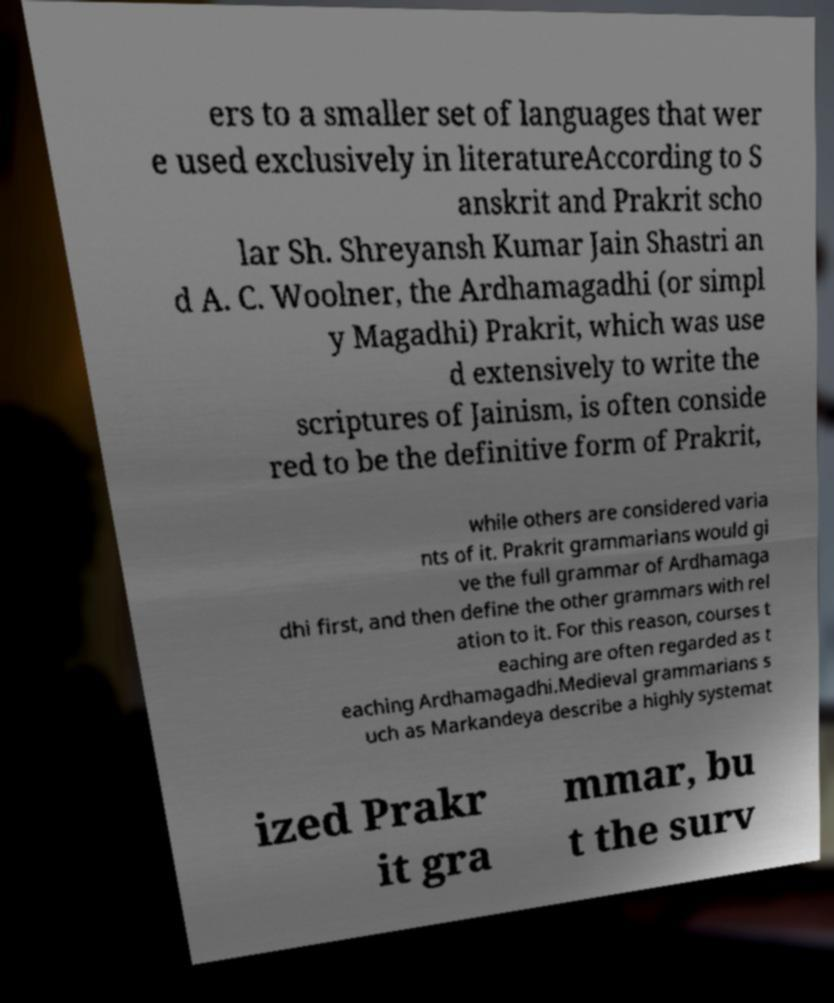For documentation purposes, I need the text within this image transcribed. Could you provide that? ers to a smaller set of languages that wer e used exclusively in literatureAccording to S anskrit and Prakrit scho lar Sh. Shreyansh Kumar Jain Shastri an d A. C. Woolner, the Ardhamagadhi (or simpl y Magadhi) Prakrit, which was use d extensively to write the scriptures of Jainism, is often conside red to be the definitive form of Prakrit, while others are considered varia nts of it. Prakrit grammarians would gi ve the full grammar of Ardhamaga dhi first, and then define the other grammars with rel ation to it. For this reason, courses t eaching are often regarded as t eaching Ardhamagadhi.Medieval grammarians s uch as Markandeya describe a highly systemat ized Prakr it gra mmar, bu t the surv 